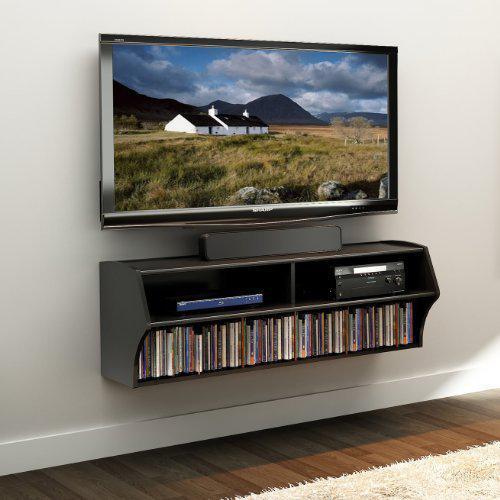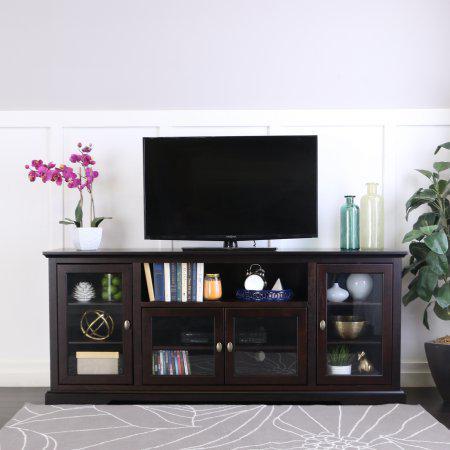The first image is the image on the left, the second image is the image on the right. Considering the images on both sides, is "One of the images shows a TV that is not mounted to the wall." valid? Answer yes or no. Yes. The first image is the image on the left, the second image is the image on the right. Evaluate the accuracy of this statement regarding the images: "At least one image shows some type of green plant near a flat-screen TV, and exactly one image contains a TV with a picture on its screen.". Is it true? Answer yes or no. Yes. 